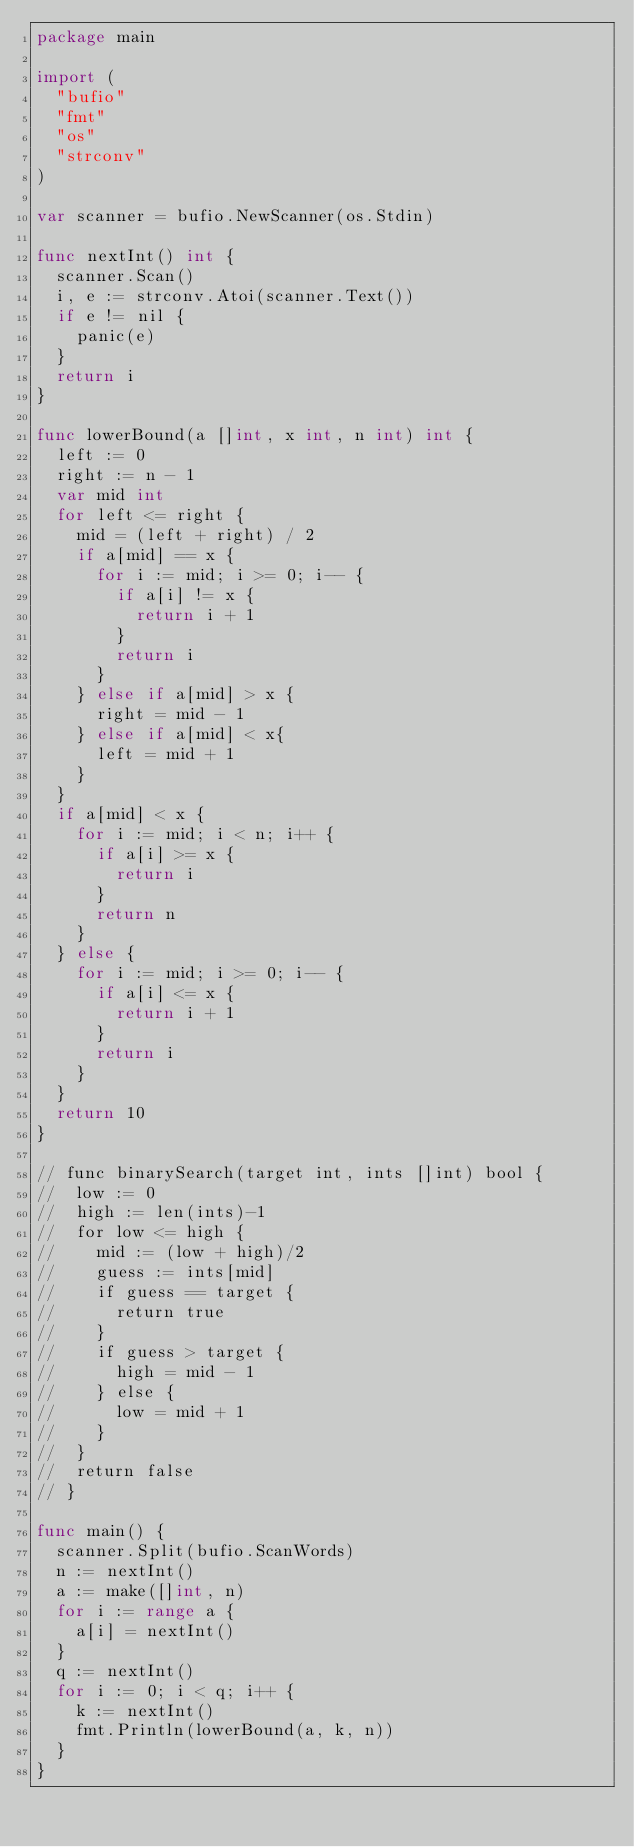<code> <loc_0><loc_0><loc_500><loc_500><_Go_>package main

import (
	"bufio"
	"fmt"
	"os"
	"strconv"
)

var scanner = bufio.NewScanner(os.Stdin)

func nextInt() int {
	scanner.Scan()
	i, e := strconv.Atoi(scanner.Text())
	if e != nil {
		panic(e)
	}
	return i
}

func lowerBound(a []int, x int, n int) int {
	left := 0
	right := n - 1
	var mid int
	for left <= right {
		mid = (left + right) / 2
		if a[mid] == x {
			for i := mid; i >= 0; i-- {
				if a[i] != x {
					return i + 1
				}
				return i
			}
		} else if a[mid] > x {
			right = mid - 1
		} else if a[mid] < x{
			left = mid + 1
		}
	}
	if a[mid] < x {
		for i := mid; i < n; i++ {
			if a[i] >= x {
				return i
			}
			return n
		}
	} else {
		for i := mid; i >= 0; i-- {
			if a[i] <= x {
				return i + 1
			}
			return i
		}
	}
	return 10
}

// func binarySearch(target int, ints []int) bool {
// 	low := 0
// 	high := len(ints)-1
// 	for low <= high {
// 		mid := (low + high)/2
// 		guess := ints[mid]
// 		if guess == target {
// 			return true
// 		}
// 		if guess > target {
// 			high = mid - 1
// 		} else {
// 			low = mid + 1
// 		}
// 	}
// 	return false
// }

func main() {
	scanner.Split(bufio.ScanWords)
	n := nextInt()
	a := make([]int, n)
	for i := range a {
		a[i] = nextInt()
	}
	q := nextInt()
	for i := 0; i < q; i++ {
		k := nextInt()
		fmt.Println(lowerBound(a, k, n))
	}
}

</code> 